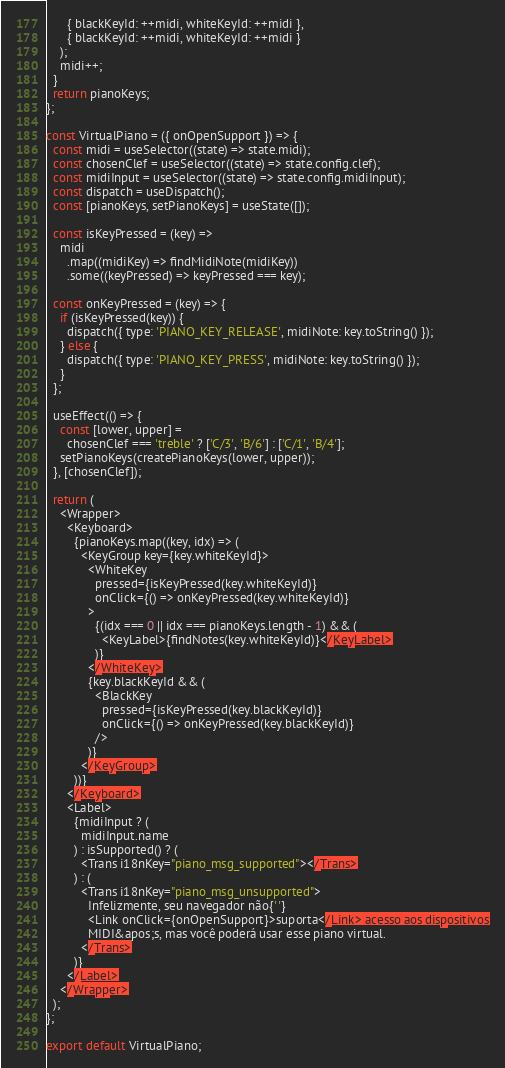Convert code to text. <code><loc_0><loc_0><loc_500><loc_500><_JavaScript_>      { blackKeyId: ++midi, whiteKeyId: ++midi },
      { blackKeyId: ++midi, whiteKeyId: ++midi }
    );
    midi++;
  }
  return pianoKeys;
};

const VirtualPiano = ({ onOpenSupport }) => {
  const midi = useSelector((state) => state.midi);
  const chosenClef = useSelector((state) => state.config.clef);
  const midiInput = useSelector((state) => state.config.midiInput);
  const dispatch = useDispatch();
  const [pianoKeys, setPianoKeys] = useState([]);

  const isKeyPressed = (key) =>
    midi
      .map((midiKey) => findMidiNote(midiKey))
      .some((keyPressed) => keyPressed === key);

  const onKeyPressed = (key) => {
    if (isKeyPressed(key)) {
      dispatch({ type: 'PIANO_KEY_RELEASE', midiNote: key.toString() });
    } else {
      dispatch({ type: 'PIANO_KEY_PRESS', midiNote: key.toString() });
    }
  };

  useEffect(() => {
    const [lower, upper] =
      chosenClef === 'treble' ? ['C/3', 'B/6'] : ['C/1', 'B/4'];
    setPianoKeys(createPianoKeys(lower, upper));
  }, [chosenClef]);

  return (
    <Wrapper>
      <Keyboard>
        {pianoKeys.map((key, idx) => (
          <KeyGroup key={key.whiteKeyId}>
            <WhiteKey
              pressed={isKeyPressed(key.whiteKeyId)}
              onClick={() => onKeyPressed(key.whiteKeyId)}
            >
              {(idx === 0 || idx === pianoKeys.length - 1) && (
                <KeyLabel>{findNotes(key.whiteKeyId)}</KeyLabel>
              )}
            </WhiteKey>
            {key.blackKeyId && (
              <BlackKey
                pressed={isKeyPressed(key.blackKeyId)}
                onClick={() => onKeyPressed(key.blackKeyId)}
              />
            )}
          </KeyGroup>
        ))}
      </Keyboard>
      <Label>
        {midiInput ? (
          midiInput.name
        ) : isSupported() ? (
          <Trans i18nKey="piano_msg_supported"></Trans>
        ) : (
          <Trans i18nKey="piano_msg_unsupported">
            Infelizmente, seu navegador não{' '}
            <Link onClick={onOpenSupport}>suporta</Link> acesso aos dispositivos
            MIDI&apos;s, mas você poderá usar esse piano virtual.
          </Trans>
        )}
      </Label>
    </Wrapper>
  );
};

export default VirtualPiano;
</code> 